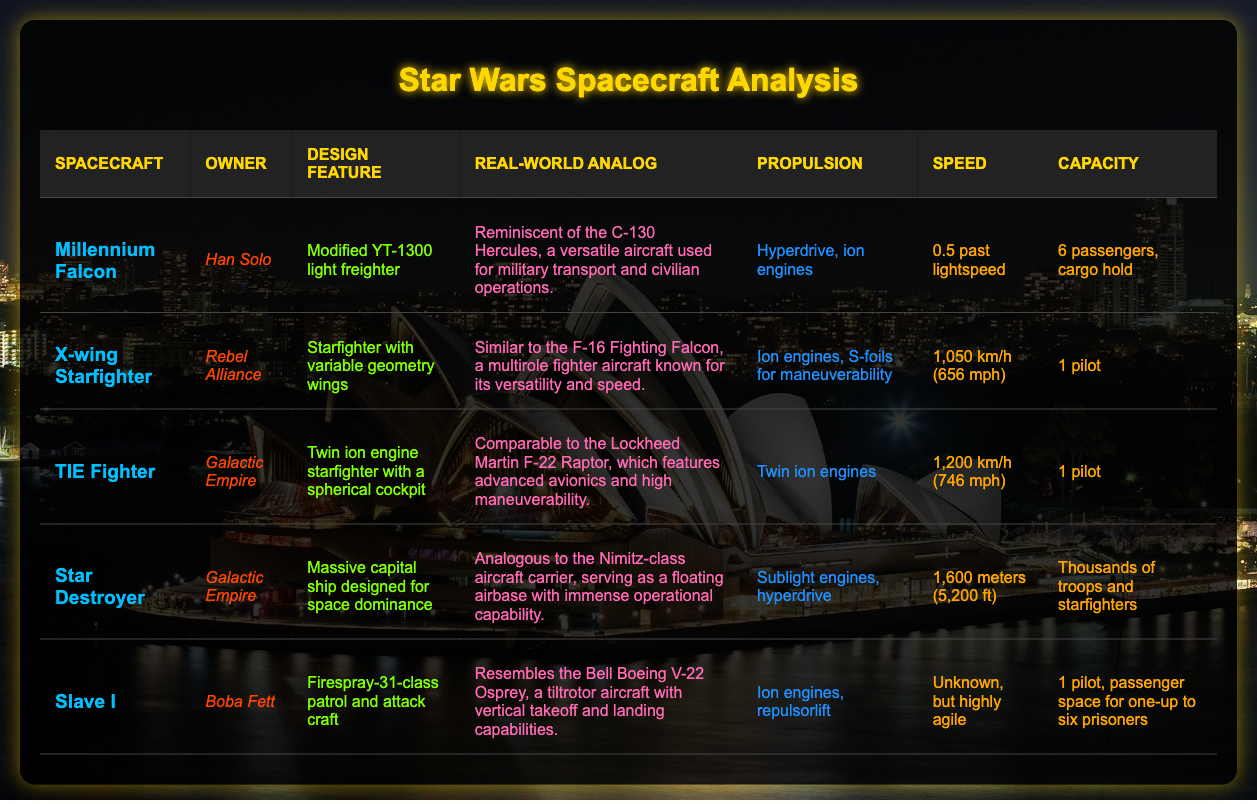What is the real-world analog for the Millennium Falcon? The table provides a specific column for the real-world analog of the Millennium Falcon, which is stated as "Millennium Falcon is reminiscent of the C-130 Hercules, a versatile aircraft used for military transport and civilian operations."
Answer: C-130 Hercules How many passengers can the X-wing Starfighter carry? The capacity column indicates that the X-wing Starfighter can carry "1 pilot."
Answer: 1 pilot Is the Star Destroyer designed for space dominance? The design feature of the Star Destroyer states it is a "Massive capital ship designed for space dominance," indicating that this statement is true.
Answer: Yes What propulsion system does Slave I use? The propulsion column lists "Ion engines, repulsorlift" for Slave I, which directly answers the question regarding its propulsion system.
Answer: Ion engines, repulsorlift Which spacecraft has the highest speed listed, and what is that speed? Comparing the speed values in the table, the Star Destroyer has its size listed instead of speed, while the TIE Fighter has a speed of "1,200 km/h (746 mph)," and the X-wing has "1,050 km/h (656 mph)." Therefore, the TIE Fighter has the highest speed of 1,200 km/h.
Answer: TIE Fighter, 1,200 km/h What is the difference in speed between the X-wing and TIE Fighter? The speed of the X-wing is "1,050 km/h (656 mph)" and the speed of the TIE Fighter is "1,200 km/h (746 mph)." The difference is calculated as 1,200 km/h - 1,050 km/h = 150 km/h.
Answer: 150 km/h What is the total capacity of the crew and troops for Star Destroyer and Slave I? The Star Destroyer has a capacity for "Thousands of troops and starfighters," while Slave I has the capacity of "1 pilot, passenger space for one-up to six prisoners," which gives a total capacity of thousands when considering troops. Therefore, the answer is dominated by the capacity of the Star Destroyer.
Answer: Thousands of troops Is there more than one pilot wise in Slave I? The capacity column specifies that Slave I has space for "1 pilot, passenger space for one-up to six prisoners," indicating that it is not designed for more than one pilot.
Answer: No Which spacecraft has a feature specified as variable geometry wings? The table states that the X-wing Starfighter has a design feature described as "Starfighter with variable geometry wings," thus answering the question related to its feature.
Answer: X-wing Starfighter 